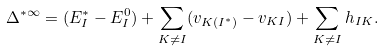<formula> <loc_0><loc_0><loc_500><loc_500>\Delta ^ { \ast \infty } = ( E _ { I } ^ { \ast } - E _ { I } ^ { 0 } ) + \sum _ { K \not = I } ( v _ { K ( I ^ { \ast } ) } - v _ { K I } ) + \sum _ { K \not = I } h _ { I K } .</formula> 